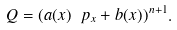Convert formula to latex. <formula><loc_0><loc_0><loc_500><loc_500>Q = ( a ( x ) \ p _ { x } + b ( x ) ) ^ { n + 1 } .</formula> 